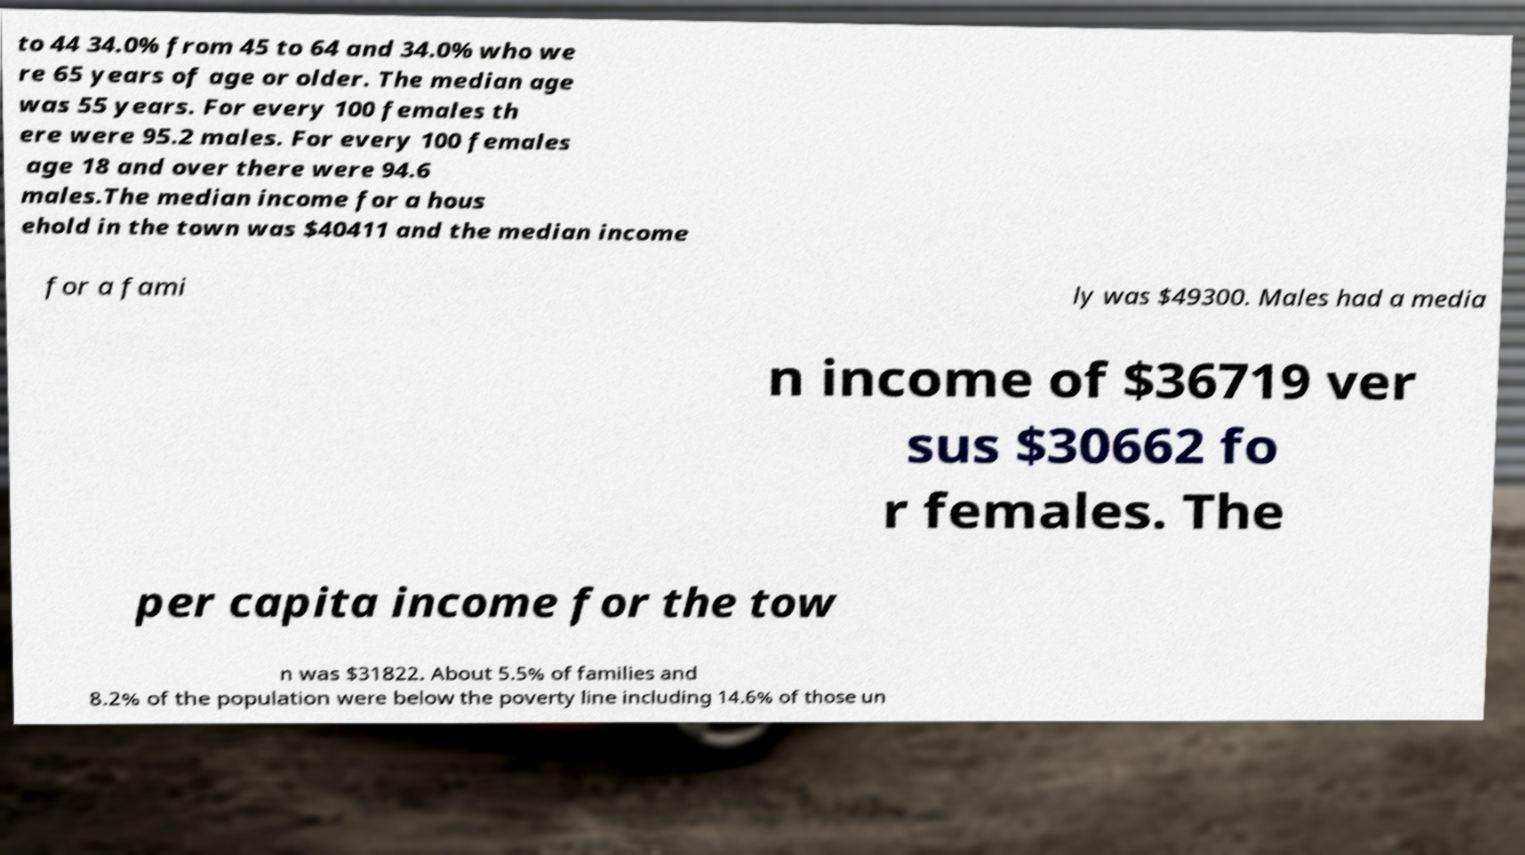There's text embedded in this image that I need extracted. Can you transcribe it verbatim? to 44 34.0% from 45 to 64 and 34.0% who we re 65 years of age or older. The median age was 55 years. For every 100 females th ere were 95.2 males. For every 100 females age 18 and over there were 94.6 males.The median income for a hous ehold in the town was $40411 and the median income for a fami ly was $49300. Males had a media n income of $36719 ver sus $30662 fo r females. The per capita income for the tow n was $31822. About 5.5% of families and 8.2% of the population were below the poverty line including 14.6% of those un 